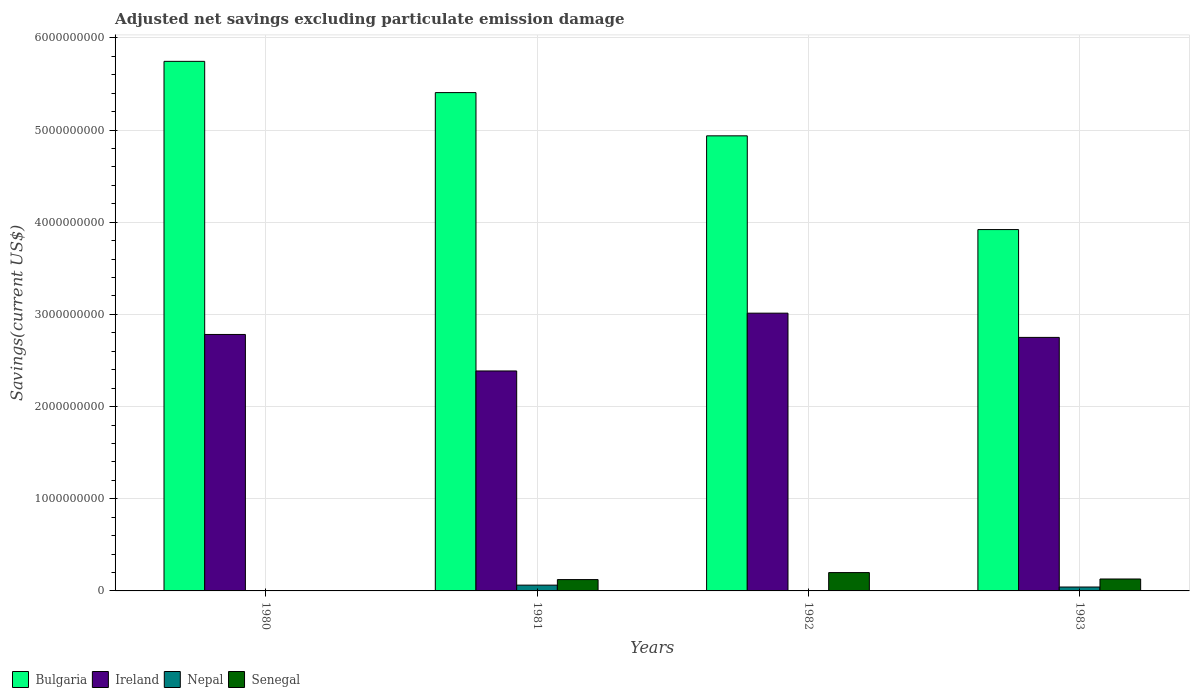How many different coloured bars are there?
Make the answer very short. 4. How many groups of bars are there?
Ensure brevity in your answer.  4. How many bars are there on the 2nd tick from the left?
Ensure brevity in your answer.  4. In how many cases, is the number of bars for a given year not equal to the number of legend labels?
Your answer should be compact. 2. What is the adjusted net savings in Senegal in 1982?
Your answer should be very brief. 1.99e+08. Across all years, what is the maximum adjusted net savings in Senegal?
Offer a very short reply. 1.99e+08. Across all years, what is the minimum adjusted net savings in Ireland?
Your answer should be compact. 2.39e+09. What is the total adjusted net savings in Nepal in the graph?
Your answer should be compact. 1.05e+08. What is the difference between the adjusted net savings in Senegal in 1981 and that in 1983?
Your response must be concise. -6.29e+06. What is the difference between the adjusted net savings in Nepal in 1981 and the adjusted net savings in Ireland in 1983?
Give a very brief answer. -2.69e+09. What is the average adjusted net savings in Bulgaria per year?
Your answer should be compact. 5.00e+09. In the year 1980, what is the difference between the adjusted net savings in Bulgaria and adjusted net savings in Ireland?
Give a very brief answer. 2.96e+09. In how many years, is the adjusted net savings in Bulgaria greater than 4000000000 US$?
Provide a succinct answer. 3. What is the ratio of the adjusted net savings in Bulgaria in 1981 to that in 1983?
Make the answer very short. 1.38. Is the adjusted net savings in Bulgaria in 1980 less than that in 1981?
Provide a succinct answer. No. Is the difference between the adjusted net savings in Bulgaria in 1980 and 1981 greater than the difference between the adjusted net savings in Ireland in 1980 and 1981?
Your answer should be compact. No. What is the difference between the highest and the second highest adjusted net savings in Ireland?
Your answer should be compact. 2.31e+08. What is the difference between the highest and the lowest adjusted net savings in Ireland?
Keep it short and to the point. 6.27e+08. In how many years, is the adjusted net savings in Nepal greater than the average adjusted net savings in Nepal taken over all years?
Provide a short and direct response. 2. Is the sum of the adjusted net savings in Ireland in 1980 and 1982 greater than the maximum adjusted net savings in Senegal across all years?
Your answer should be compact. Yes. How many years are there in the graph?
Offer a terse response. 4. What is the difference between two consecutive major ticks on the Y-axis?
Provide a succinct answer. 1.00e+09. Does the graph contain any zero values?
Keep it short and to the point. Yes. Does the graph contain grids?
Your response must be concise. Yes. Where does the legend appear in the graph?
Provide a short and direct response. Bottom left. How are the legend labels stacked?
Ensure brevity in your answer.  Horizontal. What is the title of the graph?
Offer a terse response. Adjusted net savings excluding particulate emission damage. What is the label or title of the X-axis?
Offer a very short reply. Years. What is the label or title of the Y-axis?
Keep it short and to the point. Savings(current US$). What is the Savings(current US$) in Bulgaria in 1980?
Your answer should be compact. 5.75e+09. What is the Savings(current US$) in Ireland in 1980?
Provide a short and direct response. 2.78e+09. What is the Savings(current US$) of Bulgaria in 1981?
Your answer should be compact. 5.41e+09. What is the Savings(current US$) in Ireland in 1981?
Provide a succinct answer. 2.39e+09. What is the Savings(current US$) of Nepal in 1981?
Give a very brief answer. 6.28e+07. What is the Savings(current US$) of Senegal in 1981?
Your answer should be compact. 1.23e+08. What is the Savings(current US$) of Bulgaria in 1982?
Your answer should be very brief. 4.94e+09. What is the Savings(current US$) in Ireland in 1982?
Your response must be concise. 3.01e+09. What is the Savings(current US$) of Senegal in 1982?
Ensure brevity in your answer.  1.99e+08. What is the Savings(current US$) in Bulgaria in 1983?
Give a very brief answer. 3.92e+09. What is the Savings(current US$) in Ireland in 1983?
Ensure brevity in your answer.  2.75e+09. What is the Savings(current US$) of Nepal in 1983?
Keep it short and to the point. 4.23e+07. What is the Savings(current US$) of Senegal in 1983?
Ensure brevity in your answer.  1.29e+08. Across all years, what is the maximum Savings(current US$) in Bulgaria?
Provide a succinct answer. 5.75e+09. Across all years, what is the maximum Savings(current US$) of Ireland?
Make the answer very short. 3.01e+09. Across all years, what is the maximum Savings(current US$) of Nepal?
Offer a terse response. 6.28e+07. Across all years, what is the maximum Savings(current US$) of Senegal?
Keep it short and to the point. 1.99e+08. Across all years, what is the minimum Savings(current US$) of Bulgaria?
Your answer should be very brief. 3.92e+09. Across all years, what is the minimum Savings(current US$) in Ireland?
Provide a succinct answer. 2.39e+09. Across all years, what is the minimum Savings(current US$) in Nepal?
Provide a succinct answer. 0. What is the total Savings(current US$) in Bulgaria in the graph?
Your response must be concise. 2.00e+1. What is the total Savings(current US$) of Ireland in the graph?
Your answer should be compact. 1.09e+1. What is the total Savings(current US$) in Nepal in the graph?
Keep it short and to the point. 1.05e+08. What is the total Savings(current US$) of Senegal in the graph?
Your answer should be compact. 4.51e+08. What is the difference between the Savings(current US$) in Bulgaria in 1980 and that in 1981?
Ensure brevity in your answer.  3.39e+08. What is the difference between the Savings(current US$) of Ireland in 1980 and that in 1981?
Make the answer very short. 3.96e+08. What is the difference between the Savings(current US$) in Bulgaria in 1980 and that in 1982?
Ensure brevity in your answer.  8.08e+08. What is the difference between the Savings(current US$) in Ireland in 1980 and that in 1982?
Give a very brief answer. -2.31e+08. What is the difference between the Savings(current US$) in Bulgaria in 1980 and that in 1983?
Make the answer very short. 1.83e+09. What is the difference between the Savings(current US$) of Ireland in 1980 and that in 1983?
Ensure brevity in your answer.  3.18e+07. What is the difference between the Savings(current US$) in Bulgaria in 1981 and that in 1982?
Make the answer very short. 4.69e+08. What is the difference between the Savings(current US$) of Ireland in 1981 and that in 1982?
Your answer should be compact. -6.27e+08. What is the difference between the Savings(current US$) of Senegal in 1981 and that in 1982?
Your answer should be compact. -7.59e+07. What is the difference between the Savings(current US$) in Bulgaria in 1981 and that in 1983?
Provide a succinct answer. 1.49e+09. What is the difference between the Savings(current US$) in Ireland in 1981 and that in 1983?
Your response must be concise. -3.64e+08. What is the difference between the Savings(current US$) of Nepal in 1981 and that in 1983?
Provide a short and direct response. 2.04e+07. What is the difference between the Savings(current US$) of Senegal in 1981 and that in 1983?
Give a very brief answer. -6.29e+06. What is the difference between the Savings(current US$) in Bulgaria in 1982 and that in 1983?
Ensure brevity in your answer.  1.02e+09. What is the difference between the Savings(current US$) of Ireland in 1982 and that in 1983?
Your answer should be very brief. 2.63e+08. What is the difference between the Savings(current US$) of Senegal in 1982 and that in 1983?
Your response must be concise. 6.96e+07. What is the difference between the Savings(current US$) in Bulgaria in 1980 and the Savings(current US$) in Ireland in 1981?
Give a very brief answer. 3.36e+09. What is the difference between the Savings(current US$) in Bulgaria in 1980 and the Savings(current US$) in Nepal in 1981?
Your answer should be very brief. 5.68e+09. What is the difference between the Savings(current US$) in Bulgaria in 1980 and the Savings(current US$) in Senegal in 1981?
Offer a terse response. 5.62e+09. What is the difference between the Savings(current US$) in Ireland in 1980 and the Savings(current US$) in Nepal in 1981?
Offer a terse response. 2.72e+09. What is the difference between the Savings(current US$) in Ireland in 1980 and the Savings(current US$) in Senegal in 1981?
Offer a terse response. 2.66e+09. What is the difference between the Savings(current US$) in Bulgaria in 1980 and the Savings(current US$) in Ireland in 1982?
Give a very brief answer. 2.73e+09. What is the difference between the Savings(current US$) in Bulgaria in 1980 and the Savings(current US$) in Senegal in 1982?
Your answer should be very brief. 5.55e+09. What is the difference between the Savings(current US$) in Ireland in 1980 and the Savings(current US$) in Senegal in 1982?
Keep it short and to the point. 2.58e+09. What is the difference between the Savings(current US$) of Bulgaria in 1980 and the Savings(current US$) of Ireland in 1983?
Ensure brevity in your answer.  3.00e+09. What is the difference between the Savings(current US$) of Bulgaria in 1980 and the Savings(current US$) of Nepal in 1983?
Ensure brevity in your answer.  5.70e+09. What is the difference between the Savings(current US$) in Bulgaria in 1980 and the Savings(current US$) in Senegal in 1983?
Offer a very short reply. 5.62e+09. What is the difference between the Savings(current US$) of Ireland in 1980 and the Savings(current US$) of Nepal in 1983?
Make the answer very short. 2.74e+09. What is the difference between the Savings(current US$) in Ireland in 1980 and the Savings(current US$) in Senegal in 1983?
Provide a short and direct response. 2.65e+09. What is the difference between the Savings(current US$) of Bulgaria in 1981 and the Savings(current US$) of Ireland in 1982?
Make the answer very short. 2.39e+09. What is the difference between the Savings(current US$) in Bulgaria in 1981 and the Savings(current US$) in Senegal in 1982?
Ensure brevity in your answer.  5.21e+09. What is the difference between the Savings(current US$) of Ireland in 1981 and the Savings(current US$) of Senegal in 1982?
Give a very brief answer. 2.19e+09. What is the difference between the Savings(current US$) of Nepal in 1981 and the Savings(current US$) of Senegal in 1982?
Provide a short and direct response. -1.36e+08. What is the difference between the Savings(current US$) of Bulgaria in 1981 and the Savings(current US$) of Ireland in 1983?
Your answer should be compact. 2.66e+09. What is the difference between the Savings(current US$) in Bulgaria in 1981 and the Savings(current US$) in Nepal in 1983?
Your answer should be very brief. 5.36e+09. What is the difference between the Savings(current US$) in Bulgaria in 1981 and the Savings(current US$) in Senegal in 1983?
Your response must be concise. 5.28e+09. What is the difference between the Savings(current US$) of Ireland in 1981 and the Savings(current US$) of Nepal in 1983?
Provide a succinct answer. 2.34e+09. What is the difference between the Savings(current US$) of Ireland in 1981 and the Savings(current US$) of Senegal in 1983?
Provide a succinct answer. 2.26e+09. What is the difference between the Savings(current US$) in Nepal in 1981 and the Savings(current US$) in Senegal in 1983?
Ensure brevity in your answer.  -6.66e+07. What is the difference between the Savings(current US$) in Bulgaria in 1982 and the Savings(current US$) in Ireland in 1983?
Your answer should be compact. 2.19e+09. What is the difference between the Savings(current US$) in Bulgaria in 1982 and the Savings(current US$) in Nepal in 1983?
Your response must be concise. 4.90e+09. What is the difference between the Savings(current US$) in Bulgaria in 1982 and the Savings(current US$) in Senegal in 1983?
Your answer should be compact. 4.81e+09. What is the difference between the Savings(current US$) of Ireland in 1982 and the Savings(current US$) of Nepal in 1983?
Offer a terse response. 2.97e+09. What is the difference between the Savings(current US$) in Ireland in 1982 and the Savings(current US$) in Senegal in 1983?
Make the answer very short. 2.88e+09. What is the average Savings(current US$) in Bulgaria per year?
Keep it short and to the point. 5.00e+09. What is the average Savings(current US$) of Ireland per year?
Offer a very short reply. 2.73e+09. What is the average Savings(current US$) of Nepal per year?
Keep it short and to the point. 2.63e+07. What is the average Savings(current US$) of Senegal per year?
Your answer should be compact. 1.13e+08. In the year 1980, what is the difference between the Savings(current US$) in Bulgaria and Savings(current US$) in Ireland?
Your answer should be very brief. 2.96e+09. In the year 1981, what is the difference between the Savings(current US$) of Bulgaria and Savings(current US$) of Ireland?
Give a very brief answer. 3.02e+09. In the year 1981, what is the difference between the Savings(current US$) of Bulgaria and Savings(current US$) of Nepal?
Your answer should be very brief. 5.34e+09. In the year 1981, what is the difference between the Savings(current US$) in Bulgaria and Savings(current US$) in Senegal?
Provide a succinct answer. 5.28e+09. In the year 1981, what is the difference between the Savings(current US$) in Ireland and Savings(current US$) in Nepal?
Your answer should be compact. 2.32e+09. In the year 1981, what is the difference between the Savings(current US$) of Ireland and Savings(current US$) of Senegal?
Ensure brevity in your answer.  2.26e+09. In the year 1981, what is the difference between the Savings(current US$) in Nepal and Savings(current US$) in Senegal?
Give a very brief answer. -6.03e+07. In the year 1982, what is the difference between the Savings(current US$) of Bulgaria and Savings(current US$) of Ireland?
Offer a very short reply. 1.92e+09. In the year 1982, what is the difference between the Savings(current US$) in Bulgaria and Savings(current US$) in Senegal?
Your answer should be very brief. 4.74e+09. In the year 1982, what is the difference between the Savings(current US$) of Ireland and Savings(current US$) of Senegal?
Your response must be concise. 2.81e+09. In the year 1983, what is the difference between the Savings(current US$) of Bulgaria and Savings(current US$) of Ireland?
Provide a short and direct response. 1.17e+09. In the year 1983, what is the difference between the Savings(current US$) in Bulgaria and Savings(current US$) in Nepal?
Offer a very short reply. 3.88e+09. In the year 1983, what is the difference between the Savings(current US$) of Bulgaria and Savings(current US$) of Senegal?
Provide a succinct answer. 3.79e+09. In the year 1983, what is the difference between the Savings(current US$) in Ireland and Savings(current US$) in Nepal?
Provide a succinct answer. 2.71e+09. In the year 1983, what is the difference between the Savings(current US$) in Ireland and Savings(current US$) in Senegal?
Offer a very short reply. 2.62e+09. In the year 1983, what is the difference between the Savings(current US$) in Nepal and Savings(current US$) in Senegal?
Give a very brief answer. -8.70e+07. What is the ratio of the Savings(current US$) of Bulgaria in 1980 to that in 1981?
Make the answer very short. 1.06. What is the ratio of the Savings(current US$) in Ireland in 1980 to that in 1981?
Your response must be concise. 1.17. What is the ratio of the Savings(current US$) in Bulgaria in 1980 to that in 1982?
Your answer should be compact. 1.16. What is the ratio of the Savings(current US$) in Ireland in 1980 to that in 1982?
Ensure brevity in your answer.  0.92. What is the ratio of the Savings(current US$) in Bulgaria in 1980 to that in 1983?
Provide a succinct answer. 1.47. What is the ratio of the Savings(current US$) in Ireland in 1980 to that in 1983?
Ensure brevity in your answer.  1.01. What is the ratio of the Savings(current US$) in Bulgaria in 1981 to that in 1982?
Ensure brevity in your answer.  1.09. What is the ratio of the Savings(current US$) in Ireland in 1981 to that in 1982?
Provide a succinct answer. 0.79. What is the ratio of the Savings(current US$) in Senegal in 1981 to that in 1982?
Ensure brevity in your answer.  0.62. What is the ratio of the Savings(current US$) in Bulgaria in 1981 to that in 1983?
Provide a short and direct response. 1.38. What is the ratio of the Savings(current US$) in Ireland in 1981 to that in 1983?
Offer a very short reply. 0.87. What is the ratio of the Savings(current US$) of Nepal in 1981 to that in 1983?
Give a very brief answer. 1.48. What is the ratio of the Savings(current US$) of Senegal in 1981 to that in 1983?
Your response must be concise. 0.95. What is the ratio of the Savings(current US$) in Bulgaria in 1982 to that in 1983?
Make the answer very short. 1.26. What is the ratio of the Savings(current US$) in Ireland in 1982 to that in 1983?
Provide a succinct answer. 1.1. What is the ratio of the Savings(current US$) of Senegal in 1982 to that in 1983?
Make the answer very short. 1.54. What is the difference between the highest and the second highest Savings(current US$) of Bulgaria?
Provide a short and direct response. 3.39e+08. What is the difference between the highest and the second highest Savings(current US$) in Ireland?
Make the answer very short. 2.31e+08. What is the difference between the highest and the second highest Savings(current US$) in Senegal?
Ensure brevity in your answer.  6.96e+07. What is the difference between the highest and the lowest Savings(current US$) of Bulgaria?
Keep it short and to the point. 1.83e+09. What is the difference between the highest and the lowest Savings(current US$) of Ireland?
Keep it short and to the point. 6.27e+08. What is the difference between the highest and the lowest Savings(current US$) in Nepal?
Keep it short and to the point. 6.28e+07. What is the difference between the highest and the lowest Savings(current US$) of Senegal?
Provide a succinct answer. 1.99e+08. 